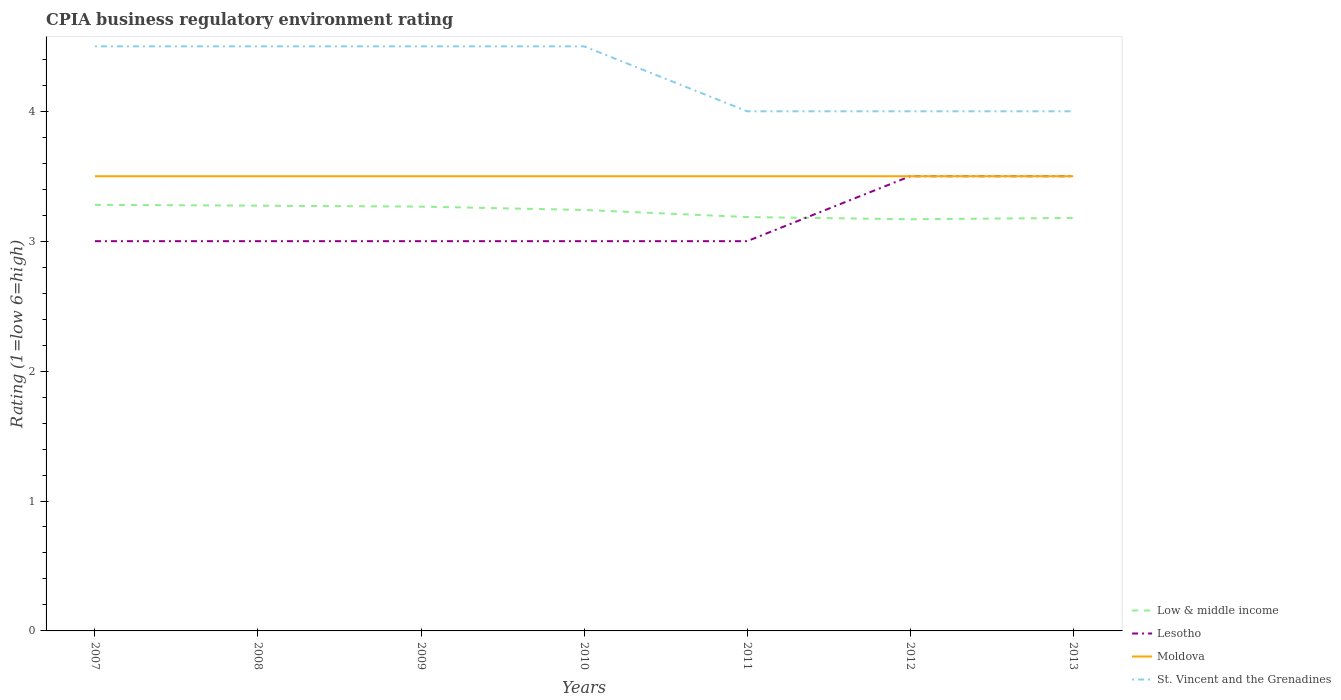How many different coloured lines are there?
Give a very brief answer. 4. Across all years, what is the maximum CPIA rating in Lesotho?
Your response must be concise. 3. What is the total CPIA rating in St. Vincent and the Grenadines in the graph?
Give a very brief answer. 0.5. What is the difference between the highest and the second highest CPIA rating in Moldova?
Offer a very short reply. 0. How many years are there in the graph?
Make the answer very short. 7. Does the graph contain any zero values?
Your answer should be very brief. No. Does the graph contain grids?
Make the answer very short. No. How are the legend labels stacked?
Your answer should be very brief. Vertical. What is the title of the graph?
Keep it short and to the point. CPIA business regulatory environment rating. Does "Panama" appear as one of the legend labels in the graph?
Provide a succinct answer. No. What is the label or title of the Y-axis?
Offer a terse response. Rating (1=low 6=high). What is the Rating (1=low 6=high) of Low & middle income in 2007?
Make the answer very short. 3.28. What is the Rating (1=low 6=high) in Moldova in 2007?
Provide a succinct answer. 3.5. What is the Rating (1=low 6=high) of Low & middle income in 2008?
Your answer should be very brief. 3.27. What is the Rating (1=low 6=high) in Lesotho in 2008?
Give a very brief answer. 3. What is the Rating (1=low 6=high) of St. Vincent and the Grenadines in 2008?
Your answer should be very brief. 4.5. What is the Rating (1=low 6=high) in Low & middle income in 2009?
Give a very brief answer. 3.27. What is the Rating (1=low 6=high) in Low & middle income in 2010?
Provide a short and direct response. 3.24. What is the Rating (1=low 6=high) in Lesotho in 2010?
Offer a terse response. 3. What is the Rating (1=low 6=high) in Low & middle income in 2011?
Offer a very short reply. 3.19. What is the Rating (1=low 6=high) in Lesotho in 2011?
Give a very brief answer. 3. What is the Rating (1=low 6=high) of Moldova in 2011?
Your answer should be compact. 3.5. What is the Rating (1=low 6=high) of St. Vincent and the Grenadines in 2011?
Your answer should be very brief. 4. What is the Rating (1=low 6=high) of Low & middle income in 2012?
Your answer should be compact. 3.17. What is the Rating (1=low 6=high) of Lesotho in 2012?
Offer a very short reply. 3.5. What is the Rating (1=low 6=high) in Moldova in 2012?
Give a very brief answer. 3.5. What is the Rating (1=low 6=high) of Low & middle income in 2013?
Your answer should be very brief. 3.18. Across all years, what is the maximum Rating (1=low 6=high) of Low & middle income?
Provide a short and direct response. 3.28. Across all years, what is the maximum Rating (1=low 6=high) of Moldova?
Give a very brief answer. 3.5. Across all years, what is the maximum Rating (1=low 6=high) of St. Vincent and the Grenadines?
Keep it short and to the point. 4.5. Across all years, what is the minimum Rating (1=low 6=high) of Low & middle income?
Offer a terse response. 3.17. Across all years, what is the minimum Rating (1=low 6=high) of Moldova?
Make the answer very short. 3.5. What is the total Rating (1=low 6=high) in Low & middle income in the graph?
Make the answer very short. 22.59. What is the total Rating (1=low 6=high) in Lesotho in the graph?
Offer a terse response. 22. What is the difference between the Rating (1=low 6=high) in Low & middle income in 2007 and that in 2008?
Keep it short and to the point. 0.01. What is the difference between the Rating (1=low 6=high) of Lesotho in 2007 and that in 2008?
Provide a short and direct response. 0. What is the difference between the Rating (1=low 6=high) in Moldova in 2007 and that in 2008?
Ensure brevity in your answer.  0. What is the difference between the Rating (1=low 6=high) of St. Vincent and the Grenadines in 2007 and that in 2008?
Your answer should be very brief. 0. What is the difference between the Rating (1=low 6=high) in Low & middle income in 2007 and that in 2009?
Give a very brief answer. 0.01. What is the difference between the Rating (1=low 6=high) in Moldova in 2007 and that in 2009?
Ensure brevity in your answer.  0. What is the difference between the Rating (1=low 6=high) in St. Vincent and the Grenadines in 2007 and that in 2009?
Offer a terse response. 0. What is the difference between the Rating (1=low 6=high) of Low & middle income in 2007 and that in 2010?
Your response must be concise. 0.04. What is the difference between the Rating (1=low 6=high) of Lesotho in 2007 and that in 2010?
Provide a short and direct response. 0. What is the difference between the Rating (1=low 6=high) in Moldova in 2007 and that in 2010?
Ensure brevity in your answer.  0. What is the difference between the Rating (1=low 6=high) in Low & middle income in 2007 and that in 2011?
Your answer should be compact. 0.09. What is the difference between the Rating (1=low 6=high) of Lesotho in 2007 and that in 2011?
Your response must be concise. 0. What is the difference between the Rating (1=low 6=high) of Moldova in 2007 and that in 2011?
Your response must be concise. 0. What is the difference between the Rating (1=low 6=high) of St. Vincent and the Grenadines in 2007 and that in 2011?
Ensure brevity in your answer.  0.5. What is the difference between the Rating (1=low 6=high) in Low & middle income in 2007 and that in 2012?
Make the answer very short. 0.11. What is the difference between the Rating (1=low 6=high) in Low & middle income in 2007 and that in 2013?
Offer a very short reply. 0.1. What is the difference between the Rating (1=low 6=high) of Lesotho in 2007 and that in 2013?
Provide a short and direct response. -0.5. What is the difference between the Rating (1=low 6=high) in Low & middle income in 2008 and that in 2009?
Offer a terse response. 0.01. What is the difference between the Rating (1=low 6=high) in Lesotho in 2008 and that in 2009?
Keep it short and to the point. 0. What is the difference between the Rating (1=low 6=high) in Low & middle income in 2008 and that in 2010?
Your answer should be very brief. 0.03. What is the difference between the Rating (1=low 6=high) of St. Vincent and the Grenadines in 2008 and that in 2010?
Your response must be concise. 0. What is the difference between the Rating (1=low 6=high) in Low & middle income in 2008 and that in 2011?
Provide a short and direct response. 0.09. What is the difference between the Rating (1=low 6=high) in Lesotho in 2008 and that in 2011?
Offer a very short reply. 0. What is the difference between the Rating (1=low 6=high) in Low & middle income in 2008 and that in 2012?
Ensure brevity in your answer.  0.1. What is the difference between the Rating (1=low 6=high) in Moldova in 2008 and that in 2012?
Offer a very short reply. 0. What is the difference between the Rating (1=low 6=high) of St. Vincent and the Grenadines in 2008 and that in 2012?
Ensure brevity in your answer.  0.5. What is the difference between the Rating (1=low 6=high) in Low & middle income in 2008 and that in 2013?
Ensure brevity in your answer.  0.09. What is the difference between the Rating (1=low 6=high) of Lesotho in 2008 and that in 2013?
Provide a succinct answer. -0.5. What is the difference between the Rating (1=low 6=high) of St. Vincent and the Grenadines in 2008 and that in 2013?
Keep it short and to the point. 0.5. What is the difference between the Rating (1=low 6=high) of Low & middle income in 2009 and that in 2010?
Keep it short and to the point. 0.03. What is the difference between the Rating (1=low 6=high) in Moldova in 2009 and that in 2010?
Provide a short and direct response. 0. What is the difference between the Rating (1=low 6=high) of St. Vincent and the Grenadines in 2009 and that in 2010?
Give a very brief answer. 0. What is the difference between the Rating (1=low 6=high) of Low & middle income in 2009 and that in 2011?
Offer a very short reply. 0.08. What is the difference between the Rating (1=low 6=high) of Lesotho in 2009 and that in 2011?
Your answer should be compact. 0. What is the difference between the Rating (1=low 6=high) in St. Vincent and the Grenadines in 2009 and that in 2011?
Your answer should be compact. 0.5. What is the difference between the Rating (1=low 6=high) of Low & middle income in 2009 and that in 2012?
Your answer should be compact. 0.1. What is the difference between the Rating (1=low 6=high) of St. Vincent and the Grenadines in 2009 and that in 2012?
Your answer should be very brief. 0.5. What is the difference between the Rating (1=low 6=high) in Low & middle income in 2009 and that in 2013?
Offer a terse response. 0.09. What is the difference between the Rating (1=low 6=high) in Lesotho in 2009 and that in 2013?
Offer a terse response. -0.5. What is the difference between the Rating (1=low 6=high) in Moldova in 2009 and that in 2013?
Make the answer very short. 0. What is the difference between the Rating (1=low 6=high) in Low & middle income in 2010 and that in 2011?
Give a very brief answer. 0.05. What is the difference between the Rating (1=low 6=high) of Lesotho in 2010 and that in 2011?
Offer a terse response. 0. What is the difference between the Rating (1=low 6=high) of Moldova in 2010 and that in 2011?
Ensure brevity in your answer.  0. What is the difference between the Rating (1=low 6=high) of Low & middle income in 2010 and that in 2012?
Make the answer very short. 0.07. What is the difference between the Rating (1=low 6=high) in Lesotho in 2010 and that in 2012?
Your answer should be compact. -0.5. What is the difference between the Rating (1=low 6=high) of Moldova in 2010 and that in 2012?
Offer a terse response. 0. What is the difference between the Rating (1=low 6=high) in Low & middle income in 2010 and that in 2013?
Make the answer very short. 0.06. What is the difference between the Rating (1=low 6=high) of Low & middle income in 2011 and that in 2012?
Offer a very short reply. 0.02. What is the difference between the Rating (1=low 6=high) in Moldova in 2011 and that in 2012?
Offer a very short reply. 0. What is the difference between the Rating (1=low 6=high) in St. Vincent and the Grenadines in 2011 and that in 2012?
Offer a very short reply. 0. What is the difference between the Rating (1=low 6=high) in Low & middle income in 2011 and that in 2013?
Offer a terse response. 0.01. What is the difference between the Rating (1=low 6=high) in Low & middle income in 2012 and that in 2013?
Your answer should be compact. -0.01. What is the difference between the Rating (1=low 6=high) in Moldova in 2012 and that in 2013?
Offer a terse response. 0. What is the difference between the Rating (1=low 6=high) of Low & middle income in 2007 and the Rating (1=low 6=high) of Lesotho in 2008?
Ensure brevity in your answer.  0.28. What is the difference between the Rating (1=low 6=high) in Low & middle income in 2007 and the Rating (1=low 6=high) in Moldova in 2008?
Ensure brevity in your answer.  -0.22. What is the difference between the Rating (1=low 6=high) of Low & middle income in 2007 and the Rating (1=low 6=high) of St. Vincent and the Grenadines in 2008?
Keep it short and to the point. -1.22. What is the difference between the Rating (1=low 6=high) in Lesotho in 2007 and the Rating (1=low 6=high) in St. Vincent and the Grenadines in 2008?
Provide a short and direct response. -1.5. What is the difference between the Rating (1=low 6=high) of Low & middle income in 2007 and the Rating (1=low 6=high) of Lesotho in 2009?
Keep it short and to the point. 0.28. What is the difference between the Rating (1=low 6=high) in Low & middle income in 2007 and the Rating (1=low 6=high) in Moldova in 2009?
Provide a succinct answer. -0.22. What is the difference between the Rating (1=low 6=high) in Low & middle income in 2007 and the Rating (1=low 6=high) in St. Vincent and the Grenadines in 2009?
Your response must be concise. -1.22. What is the difference between the Rating (1=low 6=high) of Lesotho in 2007 and the Rating (1=low 6=high) of Moldova in 2009?
Keep it short and to the point. -0.5. What is the difference between the Rating (1=low 6=high) of Moldova in 2007 and the Rating (1=low 6=high) of St. Vincent and the Grenadines in 2009?
Your response must be concise. -1. What is the difference between the Rating (1=low 6=high) of Low & middle income in 2007 and the Rating (1=low 6=high) of Lesotho in 2010?
Your answer should be very brief. 0.28. What is the difference between the Rating (1=low 6=high) of Low & middle income in 2007 and the Rating (1=low 6=high) of Moldova in 2010?
Provide a succinct answer. -0.22. What is the difference between the Rating (1=low 6=high) in Low & middle income in 2007 and the Rating (1=low 6=high) in St. Vincent and the Grenadines in 2010?
Provide a succinct answer. -1.22. What is the difference between the Rating (1=low 6=high) of Moldova in 2007 and the Rating (1=low 6=high) of St. Vincent and the Grenadines in 2010?
Keep it short and to the point. -1. What is the difference between the Rating (1=low 6=high) of Low & middle income in 2007 and the Rating (1=low 6=high) of Lesotho in 2011?
Your answer should be very brief. 0.28. What is the difference between the Rating (1=low 6=high) of Low & middle income in 2007 and the Rating (1=low 6=high) of Moldova in 2011?
Your response must be concise. -0.22. What is the difference between the Rating (1=low 6=high) of Low & middle income in 2007 and the Rating (1=low 6=high) of St. Vincent and the Grenadines in 2011?
Give a very brief answer. -0.72. What is the difference between the Rating (1=low 6=high) in Lesotho in 2007 and the Rating (1=low 6=high) in Moldova in 2011?
Offer a terse response. -0.5. What is the difference between the Rating (1=low 6=high) in Lesotho in 2007 and the Rating (1=low 6=high) in St. Vincent and the Grenadines in 2011?
Ensure brevity in your answer.  -1. What is the difference between the Rating (1=low 6=high) in Low & middle income in 2007 and the Rating (1=low 6=high) in Lesotho in 2012?
Give a very brief answer. -0.22. What is the difference between the Rating (1=low 6=high) of Low & middle income in 2007 and the Rating (1=low 6=high) of Moldova in 2012?
Ensure brevity in your answer.  -0.22. What is the difference between the Rating (1=low 6=high) of Low & middle income in 2007 and the Rating (1=low 6=high) of St. Vincent and the Grenadines in 2012?
Your answer should be very brief. -0.72. What is the difference between the Rating (1=low 6=high) of Lesotho in 2007 and the Rating (1=low 6=high) of Moldova in 2012?
Your answer should be compact. -0.5. What is the difference between the Rating (1=low 6=high) in Lesotho in 2007 and the Rating (1=low 6=high) in St. Vincent and the Grenadines in 2012?
Keep it short and to the point. -1. What is the difference between the Rating (1=low 6=high) of Moldova in 2007 and the Rating (1=low 6=high) of St. Vincent and the Grenadines in 2012?
Your answer should be compact. -0.5. What is the difference between the Rating (1=low 6=high) of Low & middle income in 2007 and the Rating (1=low 6=high) of Lesotho in 2013?
Provide a short and direct response. -0.22. What is the difference between the Rating (1=low 6=high) of Low & middle income in 2007 and the Rating (1=low 6=high) of Moldova in 2013?
Your response must be concise. -0.22. What is the difference between the Rating (1=low 6=high) in Low & middle income in 2007 and the Rating (1=low 6=high) in St. Vincent and the Grenadines in 2013?
Provide a short and direct response. -0.72. What is the difference between the Rating (1=low 6=high) in Lesotho in 2007 and the Rating (1=low 6=high) in Moldova in 2013?
Keep it short and to the point. -0.5. What is the difference between the Rating (1=low 6=high) in Lesotho in 2007 and the Rating (1=low 6=high) in St. Vincent and the Grenadines in 2013?
Offer a very short reply. -1. What is the difference between the Rating (1=low 6=high) in Low & middle income in 2008 and the Rating (1=low 6=high) in Lesotho in 2009?
Give a very brief answer. 0.27. What is the difference between the Rating (1=low 6=high) of Low & middle income in 2008 and the Rating (1=low 6=high) of Moldova in 2009?
Your answer should be compact. -0.23. What is the difference between the Rating (1=low 6=high) of Low & middle income in 2008 and the Rating (1=low 6=high) of St. Vincent and the Grenadines in 2009?
Your answer should be very brief. -1.23. What is the difference between the Rating (1=low 6=high) in Low & middle income in 2008 and the Rating (1=low 6=high) in Lesotho in 2010?
Your response must be concise. 0.27. What is the difference between the Rating (1=low 6=high) of Low & middle income in 2008 and the Rating (1=low 6=high) of Moldova in 2010?
Provide a succinct answer. -0.23. What is the difference between the Rating (1=low 6=high) in Low & middle income in 2008 and the Rating (1=low 6=high) in St. Vincent and the Grenadines in 2010?
Keep it short and to the point. -1.23. What is the difference between the Rating (1=low 6=high) of Lesotho in 2008 and the Rating (1=low 6=high) of St. Vincent and the Grenadines in 2010?
Offer a very short reply. -1.5. What is the difference between the Rating (1=low 6=high) of Moldova in 2008 and the Rating (1=low 6=high) of St. Vincent and the Grenadines in 2010?
Give a very brief answer. -1. What is the difference between the Rating (1=low 6=high) in Low & middle income in 2008 and the Rating (1=low 6=high) in Lesotho in 2011?
Provide a succinct answer. 0.27. What is the difference between the Rating (1=low 6=high) in Low & middle income in 2008 and the Rating (1=low 6=high) in Moldova in 2011?
Provide a short and direct response. -0.23. What is the difference between the Rating (1=low 6=high) in Low & middle income in 2008 and the Rating (1=low 6=high) in St. Vincent and the Grenadines in 2011?
Your response must be concise. -0.73. What is the difference between the Rating (1=low 6=high) in Lesotho in 2008 and the Rating (1=low 6=high) in Moldova in 2011?
Give a very brief answer. -0.5. What is the difference between the Rating (1=low 6=high) in Lesotho in 2008 and the Rating (1=low 6=high) in St. Vincent and the Grenadines in 2011?
Provide a succinct answer. -1. What is the difference between the Rating (1=low 6=high) of Moldova in 2008 and the Rating (1=low 6=high) of St. Vincent and the Grenadines in 2011?
Provide a succinct answer. -0.5. What is the difference between the Rating (1=low 6=high) in Low & middle income in 2008 and the Rating (1=low 6=high) in Lesotho in 2012?
Provide a short and direct response. -0.23. What is the difference between the Rating (1=low 6=high) of Low & middle income in 2008 and the Rating (1=low 6=high) of Moldova in 2012?
Your response must be concise. -0.23. What is the difference between the Rating (1=low 6=high) of Low & middle income in 2008 and the Rating (1=low 6=high) of St. Vincent and the Grenadines in 2012?
Keep it short and to the point. -0.73. What is the difference between the Rating (1=low 6=high) of Moldova in 2008 and the Rating (1=low 6=high) of St. Vincent and the Grenadines in 2012?
Provide a short and direct response. -0.5. What is the difference between the Rating (1=low 6=high) of Low & middle income in 2008 and the Rating (1=low 6=high) of Lesotho in 2013?
Your response must be concise. -0.23. What is the difference between the Rating (1=low 6=high) in Low & middle income in 2008 and the Rating (1=low 6=high) in Moldova in 2013?
Offer a terse response. -0.23. What is the difference between the Rating (1=low 6=high) in Low & middle income in 2008 and the Rating (1=low 6=high) in St. Vincent and the Grenadines in 2013?
Offer a terse response. -0.73. What is the difference between the Rating (1=low 6=high) of Lesotho in 2008 and the Rating (1=low 6=high) of St. Vincent and the Grenadines in 2013?
Your answer should be compact. -1. What is the difference between the Rating (1=low 6=high) of Moldova in 2008 and the Rating (1=low 6=high) of St. Vincent and the Grenadines in 2013?
Your answer should be very brief. -0.5. What is the difference between the Rating (1=low 6=high) in Low & middle income in 2009 and the Rating (1=low 6=high) in Lesotho in 2010?
Your answer should be compact. 0.27. What is the difference between the Rating (1=low 6=high) of Low & middle income in 2009 and the Rating (1=low 6=high) of Moldova in 2010?
Your answer should be very brief. -0.23. What is the difference between the Rating (1=low 6=high) in Low & middle income in 2009 and the Rating (1=low 6=high) in St. Vincent and the Grenadines in 2010?
Give a very brief answer. -1.23. What is the difference between the Rating (1=low 6=high) of Lesotho in 2009 and the Rating (1=low 6=high) of Moldova in 2010?
Provide a short and direct response. -0.5. What is the difference between the Rating (1=low 6=high) of Low & middle income in 2009 and the Rating (1=low 6=high) of Lesotho in 2011?
Your answer should be very brief. 0.27. What is the difference between the Rating (1=low 6=high) of Low & middle income in 2009 and the Rating (1=low 6=high) of Moldova in 2011?
Your answer should be very brief. -0.23. What is the difference between the Rating (1=low 6=high) in Low & middle income in 2009 and the Rating (1=low 6=high) in St. Vincent and the Grenadines in 2011?
Offer a very short reply. -0.73. What is the difference between the Rating (1=low 6=high) in Lesotho in 2009 and the Rating (1=low 6=high) in St. Vincent and the Grenadines in 2011?
Your answer should be very brief. -1. What is the difference between the Rating (1=low 6=high) in Low & middle income in 2009 and the Rating (1=low 6=high) in Lesotho in 2012?
Offer a very short reply. -0.23. What is the difference between the Rating (1=low 6=high) in Low & middle income in 2009 and the Rating (1=low 6=high) in Moldova in 2012?
Your response must be concise. -0.23. What is the difference between the Rating (1=low 6=high) of Low & middle income in 2009 and the Rating (1=low 6=high) of St. Vincent and the Grenadines in 2012?
Ensure brevity in your answer.  -0.73. What is the difference between the Rating (1=low 6=high) of Low & middle income in 2009 and the Rating (1=low 6=high) of Lesotho in 2013?
Your answer should be very brief. -0.23. What is the difference between the Rating (1=low 6=high) of Low & middle income in 2009 and the Rating (1=low 6=high) of Moldova in 2013?
Provide a succinct answer. -0.23. What is the difference between the Rating (1=low 6=high) in Low & middle income in 2009 and the Rating (1=low 6=high) in St. Vincent and the Grenadines in 2013?
Offer a very short reply. -0.73. What is the difference between the Rating (1=low 6=high) of Lesotho in 2009 and the Rating (1=low 6=high) of Moldova in 2013?
Keep it short and to the point. -0.5. What is the difference between the Rating (1=low 6=high) of Low & middle income in 2010 and the Rating (1=low 6=high) of Lesotho in 2011?
Your response must be concise. 0.24. What is the difference between the Rating (1=low 6=high) of Low & middle income in 2010 and the Rating (1=low 6=high) of Moldova in 2011?
Your answer should be very brief. -0.26. What is the difference between the Rating (1=low 6=high) of Low & middle income in 2010 and the Rating (1=low 6=high) of St. Vincent and the Grenadines in 2011?
Ensure brevity in your answer.  -0.76. What is the difference between the Rating (1=low 6=high) in Low & middle income in 2010 and the Rating (1=low 6=high) in Lesotho in 2012?
Offer a very short reply. -0.26. What is the difference between the Rating (1=low 6=high) in Low & middle income in 2010 and the Rating (1=low 6=high) in Moldova in 2012?
Offer a very short reply. -0.26. What is the difference between the Rating (1=low 6=high) of Low & middle income in 2010 and the Rating (1=low 6=high) of St. Vincent and the Grenadines in 2012?
Ensure brevity in your answer.  -0.76. What is the difference between the Rating (1=low 6=high) of Low & middle income in 2010 and the Rating (1=low 6=high) of Lesotho in 2013?
Make the answer very short. -0.26. What is the difference between the Rating (1=low 6=high) of Low & middle income in 2010 and the Rating (1=low 6=high) of Moldova in 2013?
Offer a terse response. -0.26. What is the difference between the Rating (1=low 6=high) in Low & middle income in 2010 and the Rating (1=low 6=high) in St. Vincent and the Grenadines in 2013?
Keep it short and to the point. -0.76. What is the difference between the Rating (1=low 6=high) of Low & middle income in 2011 and the Rating (1=low 6=high) of Lesotho in 2012?
Offer a terse response. -0.31. What is the difference between the Rating (1=low 6=high) of Low & middle income in 2011 and the Rating (1=low 6=high) of Moldova in 2012?
Make the answer very short. -0.31. What is the difference between the Rating (1=low 6=high) in Low & middle income in 2011 and the Rating (1=low 6=high) in St. Vincent and the Grenadines in 2012?
Ensure brevity in your answer.  -0.81. What is the difference between the Rating (1=low 6=high) of Lesotho in 2011 and the Rating (1=low 6=high) of Moldova in 2012?
Your answer should be compact. -0.5. What is the difference between the Rating (1=low 6=high) in Moldova in 2011 and the Rating (1=low 6=high) in St. Vincent and the Grenadines in 2012?
Offer a very short reply. -0.5. What is the difference between the Rating (1=low 6=high) in Low & middle income in 2011 and the Rating (1=low 6=high) in Lesotho in 2013?
Your response must be concise. -0.31. What is the difference between the Rating (1=low 6=high) of Low & middle income in 2011 and the Rating (1=low 6=high) of Moldova in 2013?
Your answer should be very brief. -0.31. What is the difference between the Rating (1=low 6=high) in Low & middle income in 2011 and the Rating (1=low 6=high) in St. Vincent and the Grenadines in 2013?
Ensure brevity in your answer.  -0.81. What is the difference between the Rating (1=low 6=high) in Lesotho in 2011 and the Rating (1=low 6=high) in Moldova in 2013?
Give a very brief answer. -0.5. What is the difference between the Rating (1=low 6=high) of Moldova in 2011 and the Rating (1=low 6=high) of St. Vincent and the Grenadines in 2013?
Your answer should be very brief. -0.5. What is the difference between the Rating (1=low 6=high) in Low & middle income in 2012 and the Rating (1=low 6=high) in Lesotho in 2013?
Your answer should be compact. -0.33. What is the difference between the Rating (1=low 6=high) of Low & middle income in 2012 and the Rating (1=low 6=high) of Moldova in 2013?
Your response must be concise. -0.33. What is the difference between the Rating (1=low 6=high) in Low & middle income in 2012 and the Rating (1=low 6=high) in St. Vincent and the Grenadines in 2013?
Provide a short and direct response. -0.83. What is the average Rating (1=low 6=high) in Low & middle income per year?
Your answer should be compact. 3.23. What is the average Rating (1=low 6=high) of Lesotho per year?
Keep it short and to the point. 3.14. What is the average Rating (1=low 6=high) of St. Vincent and the Grenadines per year?
Keep it short and to the point. 4.29. In the year 2007, what is the difference between the Rating (1=low 6=high) of Low & middle income and Rating (1=low 6=high) of Lesotho?
Your response must be concise. 0.28. In the year 2007, what is the difference between the Rating (1=low 6=high) in Low & middle income and Rating (1=low 6=high) in Moldova?
Provide a short and direct response. -0.22. In the year 2007, what is the difference between the Rating (1=low 6=high) of Low & middle income and Rating (1=low 6=high) of St. Vincent and the Grenadines?
Keep it short and to the point. -1.22. In the year 2007, what is the difference between the Rating (1=low 6=high) in Lesotho and Rating (1=low 6=high) in Moldova?
Your answer should be compact. -0.5. In the year 2007, what is the difference between the Rating (1=low 6=high) in Lesotho and Rating (1=low 6=high) in St. Vincent and the Grenadines?
Keep it short and to the point. -1.5. In the year 2007, what is the difference between the Rating (1=low 6=high) in Moldova and Rating (1=low 6=high) in St. Vincent and the Grenadines?
Offer a very short reply. -1. In the year 2008, what is the difference between the Rating (1=low 6=high) in Low & middle income and Rating (1=low 6=high) in Lesotho?
Your answer should be very brief. 0.27. In the year 2008, what is the difference between the Rating (1=low 6=high) of Low & middle income and Rating (1=low 6=high) of Moldova?
Keep it short and to the point. -0.23. In the year 2008, what is the difference between the Rating (1=low 6=high) in Low & middle income and Rating (1=low 6=high) in St. Vincent and the Grenadines?
Provide a succinct answer. -1.23. In the year 2008, what is the difference between the Rating (1=low 6=high) of Lesotho and Rating (1=low 6=high) of Moldova?
Make the answer very short. -0.5. In the year 2009, what is the difference between the Rating (1=low 6=high) in Low & middle income and Rating (1=low 6=high) in Lesotho?
Offer a very short reply. 0.27. In the year 2009, what is the difference between the Rating (1=low 6=high) of Low & middle income and Rating (1=low 6=high) of Moldova?
Make the answer very short. -0.23. In the year 2009, what is the difference between the Rating (1=low 6=high) in Low & middle income and Rating (1=low 6=high) in St. Vincent and the Grenadines?
Ensure brevity in your answer.  -1.23. In the year 2010, what is the difference between the Rating (1=low 6=high) of Low & middle income and Rating (1=low 6=high) of Lesotho?
Keep it short and to the point. 0.24. In the year 2010, what is the difference between the Rating (1=low 6=high) of Low & middle income and Rating (1=low 6=high) of Moldova?
Your response must be concise. -0.26. In the year 2010, what is the difference between the Rating (1=low 6=high) in Low & middle income and Rating (1=low 6=high) in St. Vincent and the Grenadines?
Provide a succinct answer. -1.26. In the year 2010, what is the difference between the Rating (1=low 6=high) in Lesotho and Rating (1=low 6=high) in Moldova?
Offer a terse response. -0.5. In the year 2010, what is the difference between the Rating (1=low 6=high) in Lesotho and Rating (1=low 6=high) in St. Vincent and the Grenadines?
Your answer should be very brief. -1.5. In the year 2011, what is the difference between the Rating (1=low 6=high) in Low & middle income and Rating (1=low 6=high) in Lesotho?
Offer a terse response. 0.19. In the year 2011, what is the difference between the Rating (1=low 6=high) in Low & middle income and Rating (1=low 6=high) in Moldova?
Ensure brevity in your answer.  -0.31. In the year 2011, what is the difference between the Rating (1=low 6=high) of Low & middle income and Rating (1=low 6=high) of St. Vincent and the Grenadines?
Provide a short and direct response. -0.81. In the year 2011, what is the difference between the Rating (1=low 6=high) of Lesotho and Rating (1=low 6=high) of Moldova?
Your response must be concise. -0.5. In the year 2011, what is the difference between the Rating (1=low 6=high) in Moldova and Rating (1=low 6=high) in St. Vincent and the Grenadines?
Make the answer very short. -0.5. In the year 2012, what is the difference between the Rating (1=low 6=high) of Low & middle income and Rating (1=low 6=high) of Lesotho?
Ensure brevity in your answer.  -0.33. In the year 2012, what is the difference between the Rating (1=low 6=high) in Low & middle income and Rating (1=low 6=high) in Moldova?
Give a very brief answer. -0.33. In the year 2012, what is the difference between the Rating (1=low 6=high) of Low & middle income and Rating (1=low 6=high) of St. Vincent and the Grenadines?
Keep it short and to the point. -0.83. In the year 2012, what is the difference between the Rating (1=low 6=high) of Lesotho and Rating (1=low 6=high) of Moldova?
Offer a very short reply. 0. In the year 2013, what is the difference between the Rating (1=low 6=high) in Low & middle income and Rating (1=low 6=high) in Lesotho?
Keep it short and to the point. -0.32. In the year 2013, what is the difference between the Rating (1=low 6=high) in Low & middle income and Rating (1=low 6=high) in Moldova?
Your answer should be compact. -0.32. In the year 2013, what is the difference between the Rating (1=low 6=high) of Low & middle income and Rating (1=low 6=high) of St. Vincent and the Grenadines?
Give a very brief answer. -0.82. In the year 2013, what is the difference between the Rating (1=low 6=high) of Lesotho and Rating (1=low 6=high) of St. Vincent and the Grenadines?
Your response must be concise. -0.5. What is the ratio of the Rating (1=low 6=high) of Low & middle income in 2007 to that in 2008?
Make the answer very short. 1. What is the ratio of the Rating (1=low 6=high) of Lesotho in 2007 to that in 2008?
Offer a very short reply. 1. What is the ratio of the Rating (1=low 6=high) of St. Vincent and the Grenadines in 2007 to that in 2008?
Provide a succinct answer. 1. What is the ratio of the Rating (1=low 6=high) in Low & middle income in 2007 to that in 2009?
Provide a succinct answer. 1. What is the ratio of the Rating (1=low 6=high) of Lesotho in 2007 to that in 2009?
Provide a short and direct response. 1. What is the ratio of the Rating (1=low 6=high) in Moldova in 2007 to that in 2009?
Offer a terse response. 1. What is the ratio of the Rating (1=low 6=high) of Low & middle income in 2007 to that in 2010?
Make the answer very short. 1.01. What is the ratio of the Rating (1=low 6=high) in Moldova in 2007 to that in 2010?
Your answer should be compact. 1. What is the ratio of the Rating (1=low 6=high) of St. Vincent and the Grenadines in 2007 to that in 2010?
Make the answer very short. 1. What is the ratio of the Rating (1=low 6=high) of Low & middle income in 2007 to that in 2011?
Give a very brief answer. 1.03. What is the ratio of the Rating (1=low 6=high) in Lesotho in 2007 to that in 2011?
Your answer should be compact. 1. What is the ratio of the Rating (1=low 6=high) in Moldova in 2007 to that in 2011?
Offer a terse response. 1. What is the ratio of the Rating (1=low 6=high) in St. Vincent and the Grenadines in 2007 to that in 2011?
Ensure brevity in your answer.  1.12. What is the ratio of the Rating (1=low 6=high) of Low & middle income in 2007 to that in 2012?
Give a very brief answer. 1.04. What is the ratio of the Rating (1=low 6=high) of Lesotho in 2007 to that in 2012?
Offer a terse response. 0.86. What is the ratio of the Rating (1=low 6=high) in Low & middle income in 2007 to that in 2013?
Provide a succinct answer. 1.03. What is the ratio of the Rating (1=low 6=high) of Moldova in 2007 to that in 2013?
Give a very brief answer. 1. What is the ratio of the Rating (1=low 6=high) in St. Vincent and the Grenadines in 2007 to that in 2013?
Your answer should be compact. 1.12. What is the ratio of the Rating (1=low 6=high) of Low & middle income in 2008 to that in 2009?
Make the answer very short. 1. What is the ratio of the Rating (1=low 6=high) of Lesotho in 2008 to that in 2009?
Offer a terse response. 1. What is the ratio of the Rating (1=low 6=high) of Low & middle income in 2008 to that in 2010?
Keep it short and to the point. 1.01. What is the ratio of the Rating (1=low 6=high) of St. Vincent and the Grenadines in 2008 to that in 2010?
Offer a very short reply. 1. What is the ratio of the Rating (1=low 6=high) of Low & middle income in 2008 to that in 2011?
Your answer should be very brief. 1.03. What is the ratio of the Rating (1=low 6=high) in Lesotho in 2008 to that in 2011?
Your answer should be compact. 1. What is the ratio of the Rating (1=low 6=high) in Low & middle income in 2008 to that in 2012?
Make the answer very short. 1.03. What is the ratio of the Rating (1=low 6=high) in Moldova in 2008 to that in 2012?
Keep it short and to the point. 1. What is the ratio of the Rating (1=low 6=high) of Low & middle income in 2008 to that in 2013?
Your answer should be compact. 1.03. What is the ratio of the Rating (1=low 6=high) of Moldova in 2008 to that in 2013?
Make the answer very short. 1. What is the ratio of the Rating (1=low 6=high) of St. Vincent and the Grenadines in 2008 to that in 2013?
Your response must be concise. 1.12. What is the ratio of the Rating (1=low 6=high) of Lesotho in 2009 to that in 2010?
Provide a succinct answer. 1. What is the ratio of the Rating (1=low 6=high) in Low & middle income in 2009 to that in 2011?
Offer a terse response. 1.03. What is the ratio of the Rating (1=low 6=high) of Lesotho in 2009 to that in 2011?
Offer a terse response. 1. What is the ratio of the Rating (1=low 6=high) of St. Vincent and the Grenadines in 2009 to that in 2011?
Your response must be concise. 1.12. What is the ratio of the Rating (1=low 6=high) in Low & middle income in 2009 to that in 2012?
Your answer should be very brief. 1.03. What is the ratio of the Rating (1=low 6=high) of St. Vincent and the Grenadines in 2009 to that in 2012?
Offer a terse response. 1.12. What is the ratio of the Rating (1=low 6=high) of Low & middle income in 2009 to that in 2013?
Give a very brief answer. 1.03. What is the ratio of the Rating (1=low 6=high) of Low & middle income in 2010 to that in 2011?
Your answer should be compact. 1.02. What is the ratio of the Rating (1=low 6=high) in Lesotho in 2010 to that in 2011?
Your response must be concise. 1. What is the ratio of the Rating (1=low 6=high) of Moldova in 2010 to that in 2011?
Offer a very short reply. 1. What is the ratio of the Rating (1=low 6=high) in Low & middle income in 2010 to that in 2012?
Offer a terse response. 1.02. What is the ratio of the Rating (1=low 6=high) in Lesotho in 2010 to that in 2012?
Provide a short and direct response. 0.86. What is the ratio of the Rating (1=low 6=high) in Moldova in 2010 to that in 2012?
Your answer should be compact. 1. What is the ratio of the Rating (1=low 6=high) of Low & middle income in 2010 to that in 2013?
Provide a short and direct response. 1.02. What is the ratio of the Rating (1=low 6=high) of Lesotho in 2010 to that in 2013?
Your answer should be very brief. 0.86. What is the ratio of the Rating (1=low 6=high) of Moldova in 2010 to that in 2013?
Your answer should be compact. 1. What is the ratio of the Rating (1=low 6=high) of St. Vincent and the Grenadines in 2010 to that in 2013?
Provide a succinct answer. 1.12. What is the ratio of the Rating (1=low 6=high) of Low & middle income in 2011 to that in 2012?
Your answer should be compact. 1.01. What is the ratio of the Rating (1=low 6=high) in Lesotho in 2011 to that in 2012?
Ensure brevity in your answer.  0.86. What is the ratio of the Rating (1=low 6=high) of Moldova in 2011 to that in 2012?
Keep it short and to the point. 1. What is the ratio of the Rating (1=low 6=high) of St. Vincent and the Grenadines in 2011 to that in 2012?
Your answer should be compact. 1. What is the ratio of the Rating (1=low 6=high) in Lesotho in 2011 to that in 2013?
Provide a succinct answer. 0.86. What is the ratio of the Rating (1=low 6=high) of Moldova in 2011 to that in 2013?
Offer a terse response. 1. What is the ratio of the Rating (1=low 6=high) in Moldova in 2012 to that in 2013?
Offer a very short reply. 1. What is the difference between the highest and the second highest Rating (1=low 6=high) of Low & middle income?
Offer a very short reply. 0.01. What is the difference between the highest and the second highest Rating (1=low 6=high) of Moldova?
Offer a very short reply. 0. What is the difference between the highest and the second highest Rating (1=low 6=high) in St. Vincent and the Grenadines?
Offer a very short reply. 0. What is the difference between the highest and the lowest Rating (1=low 6=high) in Low & middle income?
Keep it short and to the point. 0.11. What is the difference between the highest and the lowest Rating (1=low 6=high) in Moldova?
Your response must be concise. 0. What is the difference between the highest and the lowest Rating (1=low 6=high) of St. Vincent and the Grenadines?
Keep it short and to the point. 0.5. 